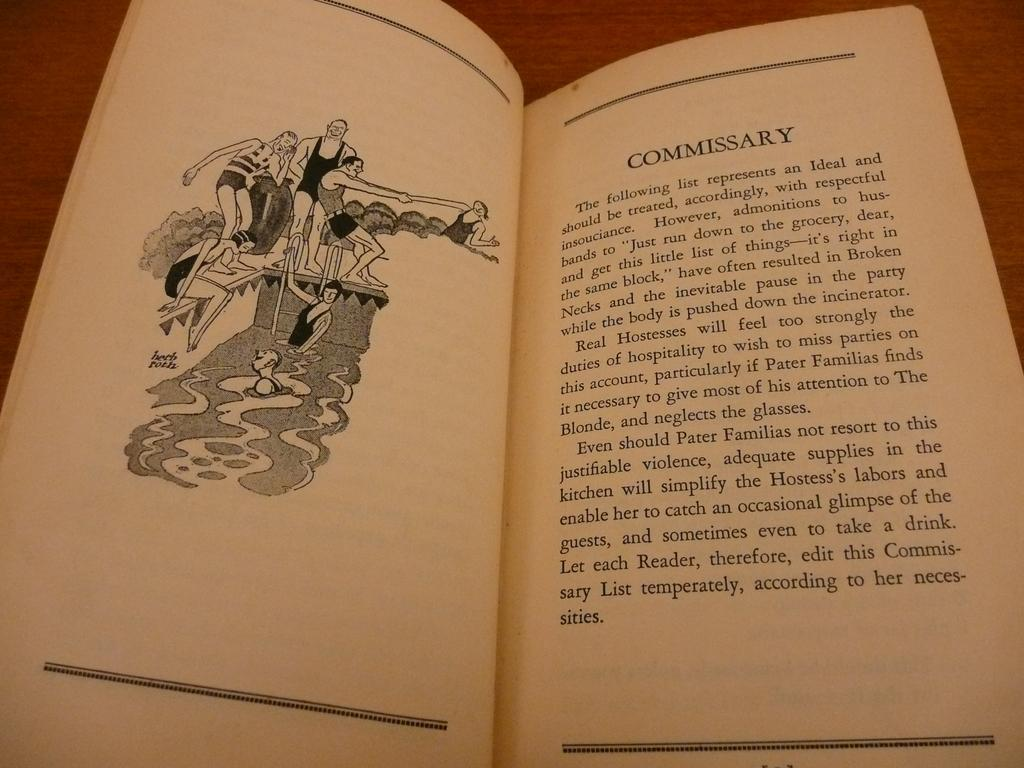<image>
Relay a brief, clear account of the picture shown. An old book opened to a page titled Commissary. 